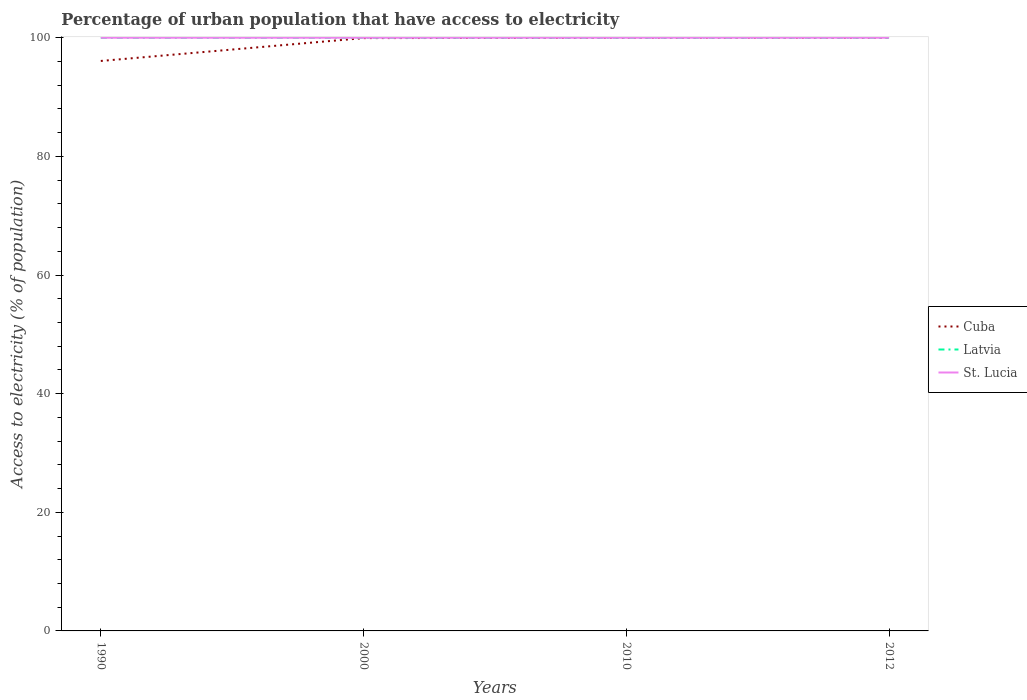How many different coloured lines are there?
Provide a succinct answer. 3. Across all years, what is the maximum percentage of urban population that have access to electricity in Latvia?
Provide a succinct answer. 100. What is the total percentage of urban population that have access to electricity in St. Lucia in the graph?
Give a very brief answer. 0. Is the percentage of urban population that have access to electricity in Latvia strictly greater than the percentage of urban population that have access to electricity in St. Lucia over the years?
Your answer should be very brief. No. How many years are there in the graph?
Provide a short and direct response. 4. Are the values on the major ticks of Y-axis written in scientific E-notation?
Your answer should be compact. No. Does the graph contain any zero values?
Provide a short and direct response. No. Does the graph contain grids?
Ensure brevity in your answer.  No. How many legend labels are there?
Ensure brevity in your answer.  3. How are the legend labels stacked?
Your answer should be very brief. Vertical. What is the title of the graph?
Your answer should be compact. Percentage of urban population that have access to electricity. Does "Ethiopia" appear as one of the legend labels in the graph?
Your response must be concise. No. What is the label or title of the X-axis?
Offer a very short reply. Years. What is the label or title of the Y-axis?
Your answer should be compact. Access to electricity (% of population). What is the Access to electricity (% of population) in Cuba in 1990?
Provide a short and direct response. 96.09. What is the Access to electricity (% of population) of Latvia in 1990?
Ensure brevity in your answer.  100. What is the Access to electricity (% of population) of St. Lucia in 1990?
Keep it short and to the point. 100. What is the Access to electricity (% of population) in Cuba in 2000?
Keep it short and to the point. 99.94. What is the Access to electricity (% of population) of Latvia in 2000?
Offer a very short reply. 100. What is the Access to electricity (% of population) of St. Lucia in 2000?
Keep it short and to the point. 100. What is the Access to electricity (% of population) in Latvia in 2010?
Give a very brief answer. 100. What is the Access to electricity (% of population) in Cuba in 2012?
Your answer should be compact. 100. What is the Access to electricity (% of population) of Latvia in 2012?
Your response must be concise. 100. What is the Access to electricity (% of population) of St. Lucia in 2012?
Ensure brevity in your answer.  100. Across all years, what is the maximum Access to electricity (% of population) in Cuba?
Give a very brief answer. 100. Across all years, what is the minimum Access to electricity (% of population) of Cuba?
Offer a terse response. 96.09. Across all years, what is the minimum Access to electricity (% of population) in St. Lucia?
Provide a succinct answer. 100. What is the total Access to electricity (% of population) of Cuba in the graph?
Provide a short and direct response. 396.02. What is the total Access to electricity (% of population) of Latvia in the graph?
Your response must be concise. 400. What is the total Access to electricity (% of population) of St. Lucia in the graph?
Your response must be concise. 400. What is the difference between the Access to electricity (% of population) of Cuba in 1990 and that in 2000?
Provide a short and direct response. -3.85. What is the difference between the Access to electricity (% of population) in Latvia in 1990 and that in 2000?
Offer a very short reply. 0. What is the difference between the Access to electricity (% of population) in St. Lucia in 1990 and that in 2000?
Offer a terse response. 0. What is the difference between the Access to electricity (% of population) in Cuba in 1990 and that in 2010?
Your response must be concise. -3.91. What is the difference between the Access to electricity (% of population) of Latvia in 1990 and that in 2010?
Your answer should be compact. 0. What is the difference between the Access to electricity (% of population) of Cuba in 1990 and that in 2012?
Offer a very short reply. -3.91. What is the difference between the Access to electricity (% of population) in St. Lucia in 1990 and that in 2012?
Keep it short and to the point. 0. What is the difference between the Access to electricity (% of population) in Cuba in 2000 and that in 2010?
Your response must be concise. -0.06. What is the difference between the Access to electricity (% of population) of Cuba in 2000 and that in 2012?
Your response must be concise. -0.06. What is the difference between the Access to electricity (% of population) in Latvia in 2000 and that in 2012?
Make the answer very short. 0. What is the difference between the Access to electricity (% of population) of St. Lucia in 2010 and that in 2012?
Keep it short and to the point. 0. What is the difference between the Access to electricity (% of population) in Cuba in 1990 and the Access to electricity (% of population) in Latvia in 2000?
Give a very brief answer. -3.91. What is the difference between the Access to electricity (% of population) of Cuba in 1990 and the Access to electricity (% of population) of St. Lucia in 2000?
Provide a succinct answer. -3.91. What is the difference between the Access to electricity (% of population) of Cuba in 1990 and the Access to electricity (% of population) of Latvia in 2010?
Your answer should be compact. -3.91. What is the difference between the Access to electricity (% of population) of Cuba in 1990 and the Access to electricity (% of population) of St. Lucia in 2010?
Give a very brief answer. -3.91. What is the difference between the Access to electricity (% of population) of Latvia in 1990 and the Access to electricity (% of population) of St. Lucia in 2010?
Make the answer very short. 0. What is the difference between the Access to electricity (% of population) in Cuba in 1990 and the Access to electricity (% of population) in Latvia in 2012?
Your answer should be compact. -3.91. What is the difference between the Access to electricity (% of population) of Cuba in 1990 and the Access to electricity (% of population) of St. Lucia in 2012?
Give a very brief answer. -3.91. What is the difference between the Access to electricity (% of population) in Latvia in 1990 and the Access to electricity (% of population) in St. Lucia in 2012?
Your response must be concise. 0. What is the difference between the Access to electricity (% of population) in Cuba in 2000 and the Access to electricity (% of population) in Latvia in 2010?
Provide a succinct answer. -0.06. What is the difference between the Access to electricity (% of population) in Cuba in 2000 and the Access to electricity (% of population) in St. Lucia in 2010?
Keep it short and to the point. -0.06. What is the difference between the Access to electricity (% of population) in Cuba in 2000 and the Access to electricity (% of population) in Latvia in 2012?
Keep it short and to the point. -0.06. What is the difference between the Access to electricity (% of population) of Cuba in 2000 and the Access to electricity (% of population) of St. Lucia in 2012?
Your answer should be very brief. -0.06. What is the difference between the Access to electricity (% of population) in Latvia in 2000 and the Access to electricity (% of population) in St. Lucia in 2012?
Provide a succinct answer. 0. What is the average Access to electricity (% of population) of Cuba per year?
Offer a terse response. 99.01. In the year 1990, what is the difference between the Access to electricity (% of population) in Cuba and Access to electricity (% of population) in Latvia?
Offer a very short reply. -3.91. In the year 1990, what is the difference between the Access to electricity (% of population) of Cuba and Access to electricity (% of population) of St. Lucia?
Your answer should be compact. -3.91. In the year 2000, what is the difference between the Access to electricity (% of population) of Cuba and Access to electricity (% of population) of Latvia?
Your response must be concise. -0.06. In the year 2000, what is the difference between the Access to electricity (% of population) in Cuba and Access to electricity (% of population) in St. Lucia?
Your response must be concise. -0.06. In the year 2000, what is the difference between the Access to electricity (% of population) in Latvia and Access to electricity (% of population) in St. Lucia?
Your answer should be very brief. 0. In the year 2010, what is the difference between the Access to electricity (% of population) in Cuba and Access to electricity (% of population) in St. Lucia?
Offer a very short reply. 0. In the year 2012, what is the difference between the Access to electricity (% of population) of Cuba and Access to electricity (% of population) of St. Lucia?
Provide a succinct answer. 0. What is the ratio of the Access to electricity (% of population) of Cuba in 1990 to that in 2000?
Your answer should be compact. 0.96. What is the ratio of the Access to electricity (% of population) in Latvia in 1990 to that in 2000?
Provide a succinct answer. 1. What is the ratio of the Access to electricity (% of population) in St. Lucia in 1990 to that in 2000?
Your answer should be very brief. 1. What is the ratio of the Access to electricity (% of population) in Cuba in 1990 to that in 2010?
Your response must be concise. 0.96. What is the ratio of the Access to electricity (% of population) in Cuba in 1990 to that in 2012?
Ensure brevity in your answer.  0.96. What is the ratio of the Access to electricity (% of population) in St. Lucia in 1990 to that in 2012?
Give a very brief answer. 1. What is the ratio of the Access to electricity (% of population) in Cuba in 2000 to that in 2010?
Your answer should be very brief. 1. What is the ratio of the Access to electricity (% of population) of St. Lucia in 2000 to that in 2010?
Your answer should be compact. 1. What is the ratio of the Access to electricity (% of population) in Cuba in 2000 to that in 2012?
Give a very brief answer. 1. What is the ratio of the Access to electricity (% of population) in Latvia in 2000 to that in 2012?
Your answer should be compact. 1. What is the ratio of the Access to electricity (% of population) in Cuba in 2010 to that in 2012?
Give a very brief answer. 1. What is the ratio of the Access to electricity (% of population) of St. Lucia in 2010 to that in 2012?
Your response must be concise. 1. What is the difference between the highest and the second highest Access to electricity (% of population) of Latvia?
Your answer should be compact. 0. What is the difference between the highest and the second highest Access to electricity (% of population) in St. Lucia?
Give a very brief answer. 0. What is the difference between the highest and the lowest Access to electricity (% of population) in Cuba?
Your response must be concise. 3.91. What is the difference between the highest and the lowest Access to electricity (% of population) of Latvia?
Your answer should be compact. 0. 